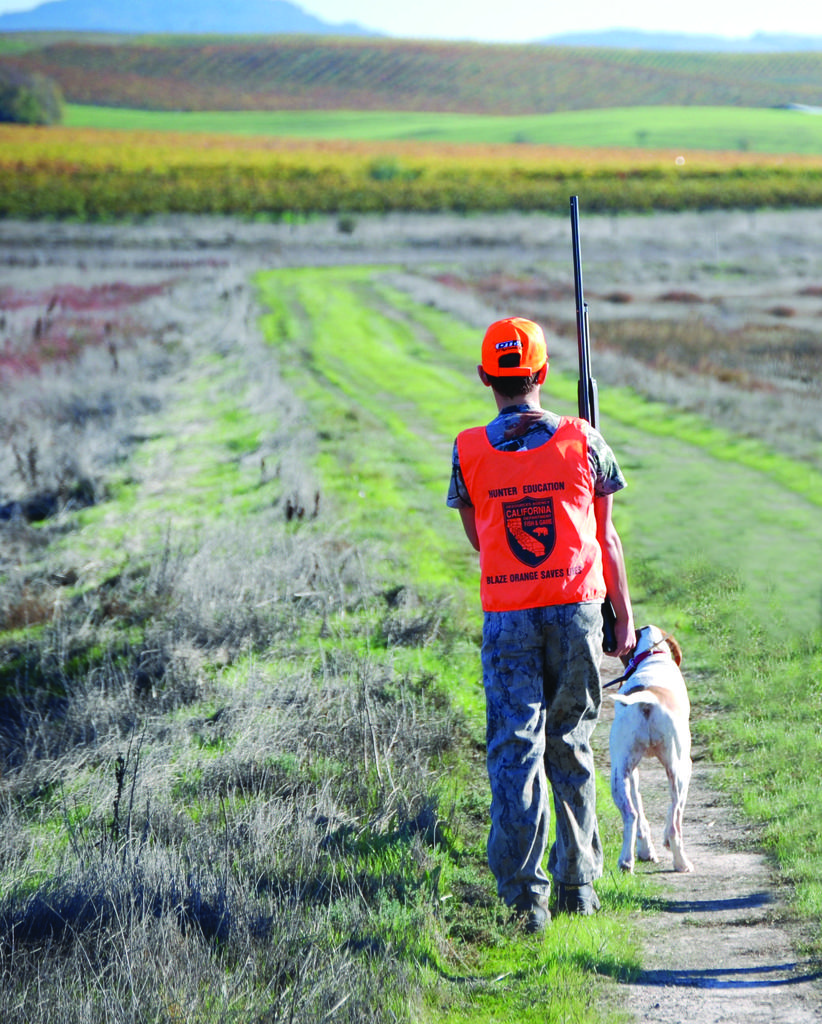What is the main subject of the image? There is a person in the image. Can you describe the person's attire? The person is wearing a cap. What is the person holding in the image? The person is holding a gun. What animal is beside the person? There is a dog beside the person. What can be seen in the background of the image? There is a field, mountains, and the sky visible in the background of the image. What type of wood is being used to construct the office building in the image? There is no office building present in the image; it features a person, a dog, and a background with a field, mountains, and sky. 